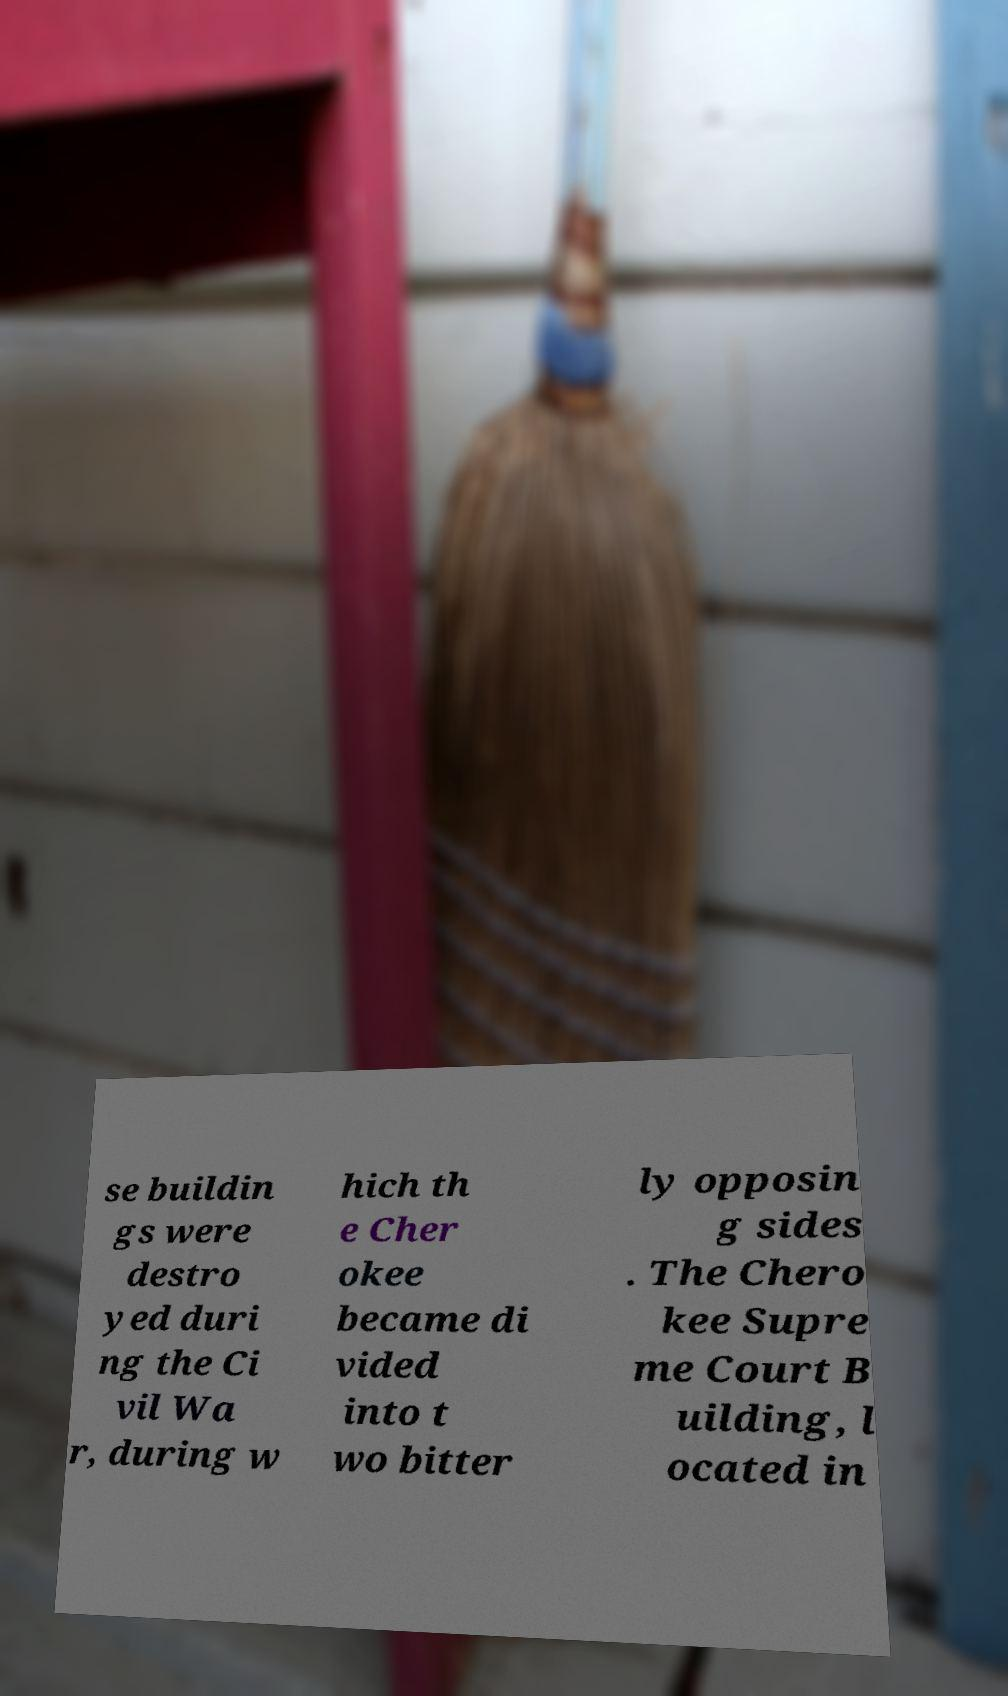I need the written content from this picture converted into text. Can you do that? se buildin gs were destro yed duri ng the Ci vil Wa r, during w hich th e Cher okee became di vided into t wo bitter ly opposin g sides . The Chero kee Supre me Court B uilding, l ocated in 